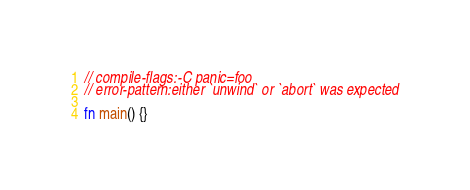Convert code to text. <code><loc_0><loc_0><loc_500><loc_500><_Rust_>// compile-flags:-C panic=foo
// error-pattern:either `unwind` or `abort` was expected

fn main() {}
</code> 